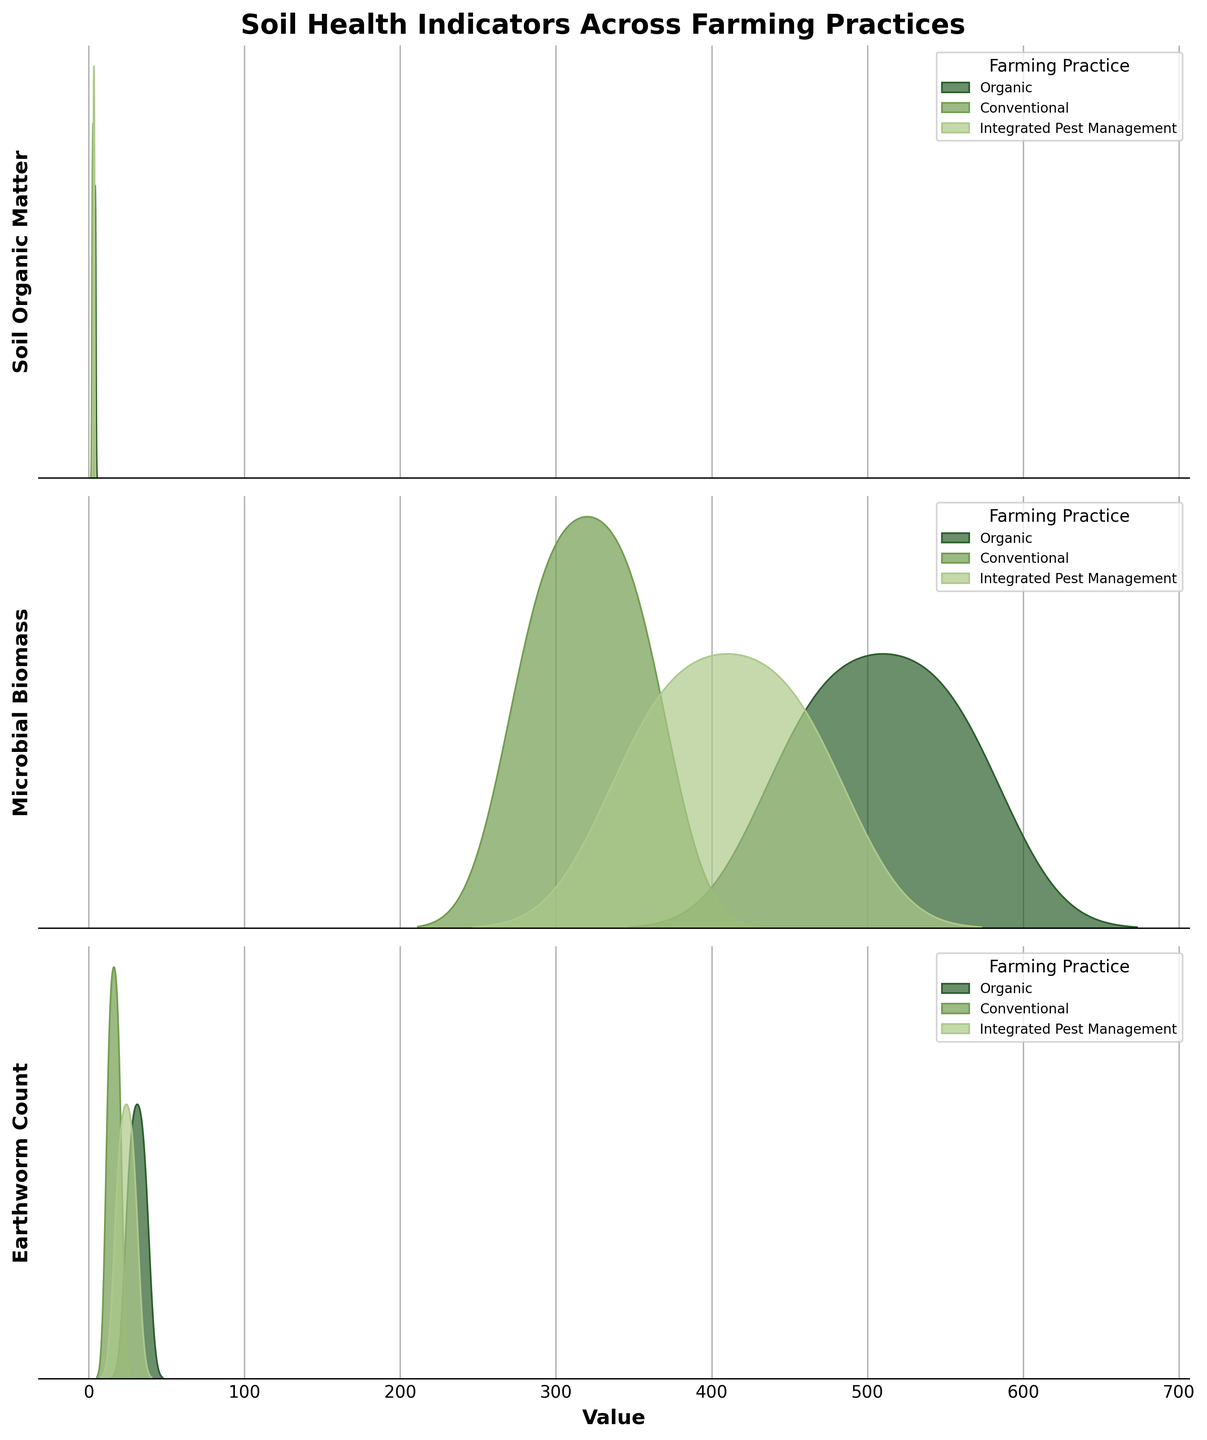What is the title of the plot? The title of the plot is usually found at the top of the figure in a prominent font. In this case, it's "Soil Health Indicators Across Farming Practices."
Answer: Soil Health Indicators Across Farming Practices How many categories of farming practices are represented in the plot? To find the number of farming practices, look at the legend, which lists each category of farming practice. Here, there are three: Organic, Conventional, and Integrated Pest Management.
Answer: 3 Which soil health indicator has the highest values under Organic farming? By examining the ridgeline plots for each soil health indicator under Organic farming, note that "Microbial Biomass" shows the highest values, ranging between 450 and 570.
Answer: Microbial Biomass What's the range of values for Soil Organic Matter in Integrated Pest Management? Locate the ridgeline plot specific to Soil Organic Matter for Integrated Pest Management. The range of values can be deduced from where the curve starts and ends which in this case is between 2.8 and 3.6.
Answer: 2.8 to 3.6 Which farming practice shows the lowest values for Earthworm Count? Compare the Earthworm Count ridgeline plots for each farming practice. The curve for Conventional farming starts at a lower value (around 12) than the others.
Answer: Conventional Do Organic and Integrated Pest Management have overlapping ranges for Microbial Biomass? Look at the Microbial Biomass ridgeline plots for both practices. The ranges are 450-570 for Organic and 350-470 for Integrated Pest Management, which overlap between 450 and 470.
Answer: Yes For Soil Organic Matter, which farming practice has the broadest range? Evaluate the spread of the ridgeline plots for Soil Organic Matter across the practices. Organic farming has a spread from 3.2 to 4.3, which is broader compared to the others.
Answer: Organic Is there any farming practice where the Earthworm Count does not exceed 30? Examine the ridgeline plots for Earthworm Count. The Conventional farming plot ends at 20, which does not exceed 30.
Answer: Conventional What is the overall trend in Soil Organic Matter values when moving from Conventional to Organic farming? Observe and compare the positioning of the peak values for Soil Organic Matter across the farming practices. Values increase from Conventional to Integrated Pest Management to Organic.
Answer: Increasing 